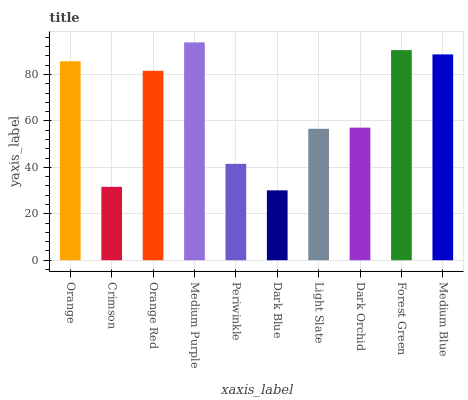Is Dark Blue the minimum?
Answer yes or no. Yes. Is Medium Purple the maximum?
Answer yes or no. Yes. Is Crimson the minimum?
Answer yes or no. No. Is Crimson the maximum?
Answer yes or no. No. Is Orange greater than Crimson?
Answer yes or no. Yes. Is Crimson less than Orange?
Answer yes or no. Yes. Is Crimson greater than Orange?
Answer yes or no. No. Is Orange less than Crimson?
Answer yes or no. No. Is Orange Red the high median?
Answer yes or no. Yes. Is Dark Orchid the low median?
Answer yes or no. Yes. Is Medium Blue the high median?
Answer yes or no. No. Is Dark Blue the low median?
Answer yes or no. No. 